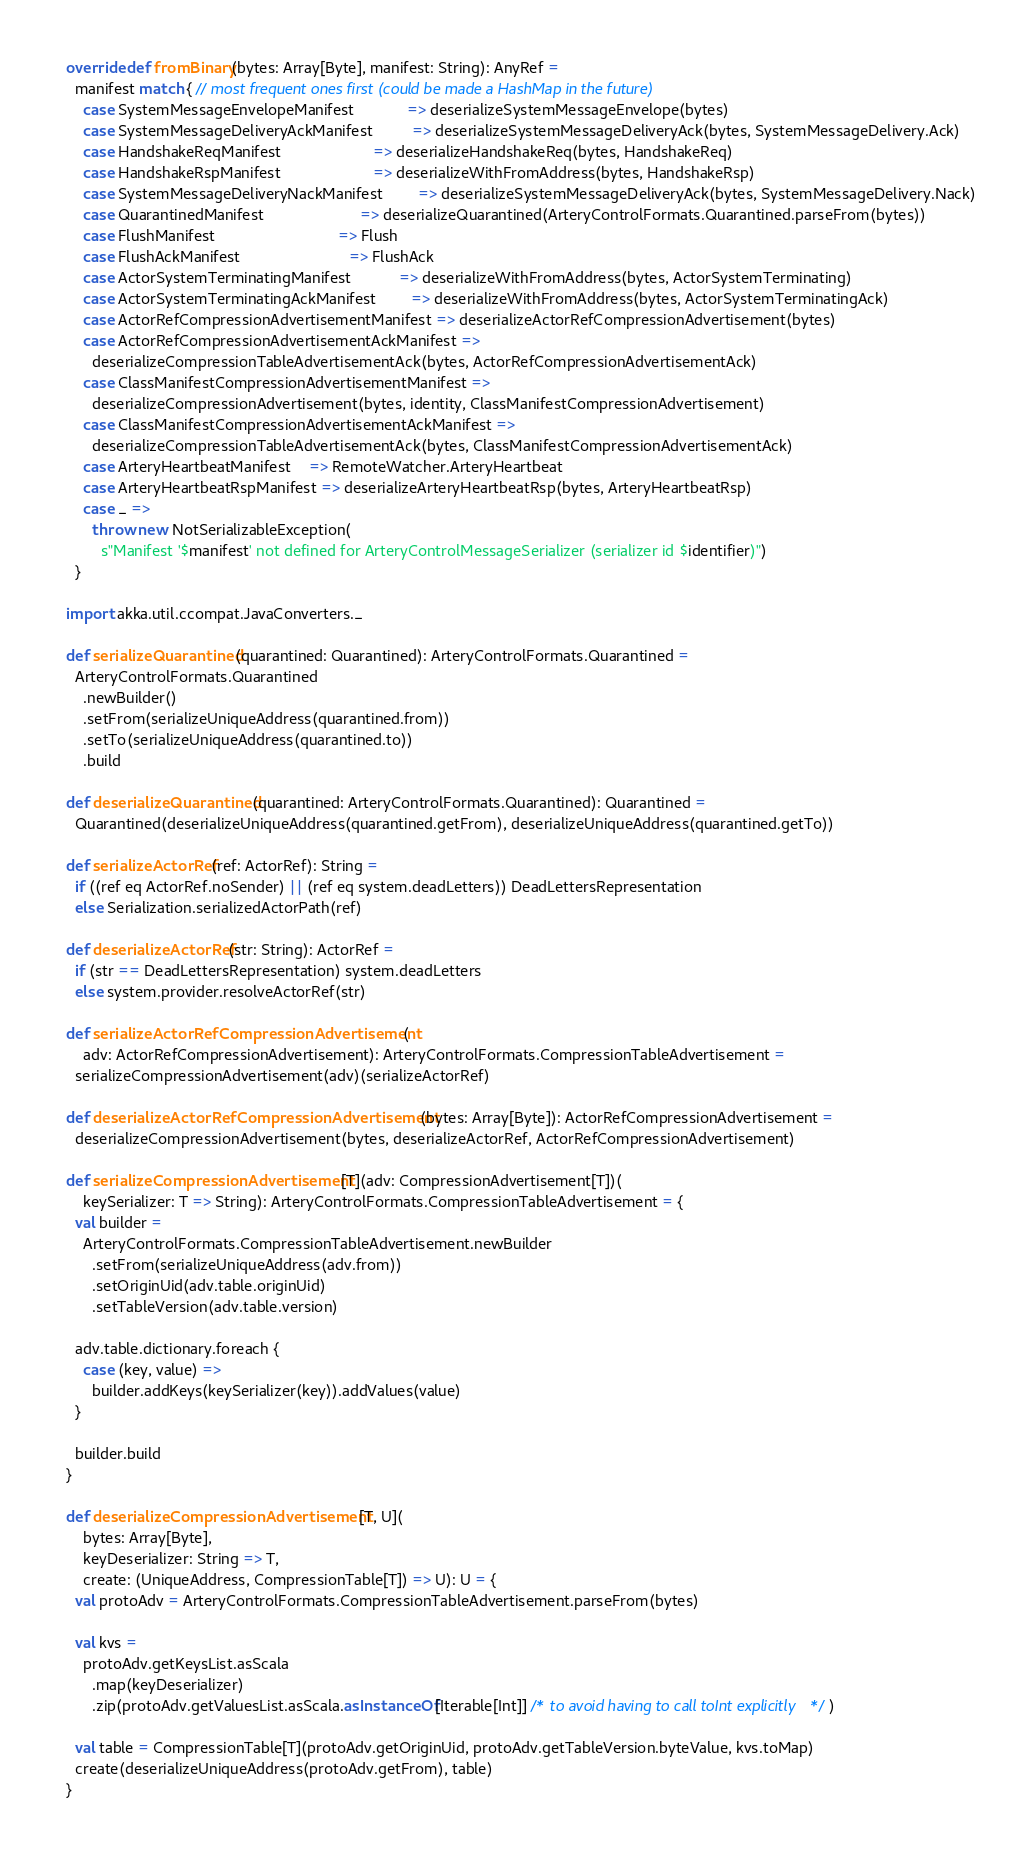Convert code to text. <code><loc_0><loc_0><loc_500><loc_500><_Scala_>
  override def fromBinary(bytes: Array[Byte], manifest: String): AnyRef =
    manifest match { // most frequent ones first (could be made a HashMap in the future)
      case SystemMessageEnvelopeManifest            => deserializeSystemMessageEnvelope(bytes)
      case SystemMessageDeliveryAckManifest         => deserializeSystemMessageDeliveryAck(bytes, SystemMessageDelivery.Ack)
      case HandshakeReqManifest                     => deserializeHandshakeReq(bytes, HandshakeReq)
      case HandshakeRspManifest                     => deserializeWithFromAddress(bytes, HandshakeRsp)
      case SystemMessageDeliveryNackManifest        => deserializeSystemMessageDeliveryAck(bytes, SystemMessageDelivery.Nack)
      case QuarantinedManifest                      => deserializeQuarantined(ArteryControlFormats.Quarantined.parseFrom(bytes))
      case FlushManifest                            => Flush
      case FlushAckManifest                         => FlushAck
      case ActorSystemTerminatingManifest           => deserializeWithFromAddress(bytes, ActorSystemTerminating)
      case ActorSystemTerminatingAckManifest        => deserializeWithFromAddress(bytes, ActorSystemTerminatingAck)
      case ActorRefCompressionAdvertisementManifest => deserializeActorRefCompressionAdvertisement(bytes)
      case ActorRefCompressionAdvertisementAckManifest =>
        deserializeCompressionTableAdvertisementAck(bytes, ActorRefCompressionAdvertisementAck)
      case ClassManifestCompressionAdvertisementManifest =>
        deserializeCompressionAdvertisement(bytes, identity, ClassManifestCompressionAdvertisement)
      case ClassManifestCompressionAdvertisementAckManifest =>
        deserializeCompressionTableAdvertisementAck(bytes, ClassManifestCompressionAdvertisementAck)
      case ArteryHeartbeatManifest    => RemoteWatcher.ArteryHeartbeat
      case ArteryHeartbeatRspManifest => deserializeArteryHeartbeatRsp(bytes, ArteryHeartbeatRsp)
      case _ =>
        throw new NotSerializableException(
          s"Manifest '$manifest' not defined for ArteryControlMessageSerializer (serializer id $identifier)")
    }

  import akka.util.ccompat.JavaConverters._

  def serializeQuarantined(quarantined: Quarantined): ArteryControlFormats.Quarantined =
    ArteryControlFormats.Quarantined
      .newBuilder()
      .setFrom(serializeUniqueAddress(quarantined.from))
      .setTo(serializeUniqueAddress(quarantined.to))
      .build

  def deserializeQuarantined(quarantined: ArteryControlFormats.Quarantined): Quarantined =
    Quarantined(deserializeUniqueAddress(quarantined.getFrom), deserializeUniqueAddress(quarantined.getTo))

  def serializeActorRef(ref: ActorRef): String =
    if ((ref eq ActorRef.noSender) || (ref eq system.deadLetters)) DeadLettersRepresentation
    else Serialization.serializedActorPath(ref)

  def deserializeActorRef(str: String): ActorRef =
    if (str == DeadLettersRepresentation) system.deadLetters
    else system.provider.resolveActorRef(str)

  def serializeActorRefCompressionAdvertisement(
      adv: ActorRefCompressionAdvertisement): ArteryControlFormats.CompressionTableAdvertisement =
    serializeCompressionAdvertisement(adv)(serializeActorRef)

  def deserializeActorRefCompressionAdvertisement(bytes: Array[Byte]): ActorRefCompressionAdvertisement =
    deserializeCompressionAdvertisement(bytes, deserializeActorRef, ActorRefCompressionAdvertisement)

  def serializeCompressionAdvertisement[T](adv: CompressionAdvertisement[T])(
      keySerializer: T => String): ArteryControlFormats.CompressionTableAdvertisement = {
    val builder =
      ArteryControlFormats.CompressionTableAdvertisement.newBuilder
        .setFrom(serializeUniqueAddress(adv.from))
        .setOriginUid(adv.table.originUid)
        .setTableVersion(adv.table.version)

    adv.table.dictionary.foreach {
      case (key, value) =>
        builder.addKeys(keySerializer(key)).addValues(value)
    }

    builder.build
  }

  def deserializeCompressionAdvertisement[T, U](
      bytes: Array[Byte],
      keyDeserializer: String => T,
      create: (UniqueAddress, CompressionTable[T]) => U): U = {
    val protoAdv = ArteryControlFormats.CompressionTableAdvertisement.parseFrom(bytes)

    val kvs =
      protoAdv.getKeysList.asScala
        .map(keyDeserializer)
        .zip(protoAdv.getValuesList.asScala.asInstanceOf[Iterable[Int]] /* to avoid having to call toInt explicitly */ )

    val table = CompressionTable[T](protoAdv.getOriginUid, protoAdv.getTableVersion.byteValue, kvs.toMap)
    create(deserializeUniqueAddress(protoAdv.getFrom), table)
  }
</code> 